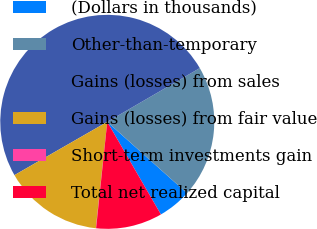<chart> <loc_0><loc_0><loc_500><loc_500><pie_chart><fcel>(Dollars in thousands)<fcel>Other-than-temporary<fcel>Gains (losses) from sales<fcel>Gains (losses) from fair value<fcel>Short-term investments gain<fcel>Total net realized capital<nl><fcel>5.03%<fcel>19.99%<fcel>49.91%<fcel>15.0%<fcel>0.04%<fcel>10.02%<nl></chart> 